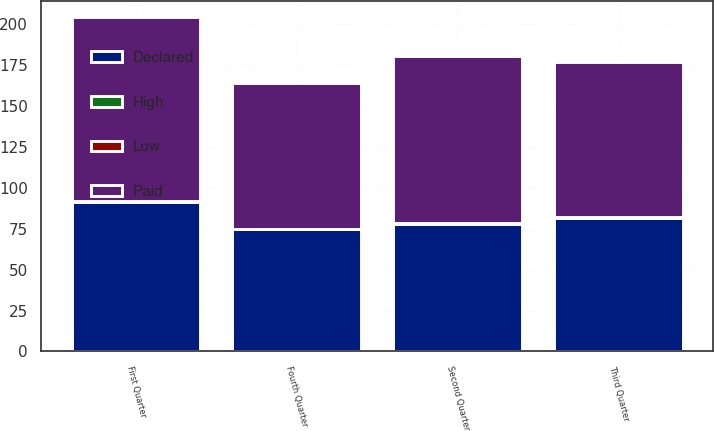Convert chart to OTSL. <chart><loc_0><loc_0><loc_500><loc_500><stacked_bar_chart><ecel><fcel>First Quarter<fcel>Second Quarter<fcel>Third Quarter<fcel>Fourth Quarter<nl><fcel>Paid<fcel>112.09<fcel>102.13<fcel>94.87<fcel>89.08<nl><fcel>Declared<fcel>91.48<fcel>77.93<fcel>81.55<fcel>74.5<nl><fcel>High<fcel>0.17<fcel>0.17<fcel>0.17<fcel>0.17<nl><fcel>Low<fcel>0.15<fcel>0.17<fcel>0.17<fcel>0.17<nl></chart> 